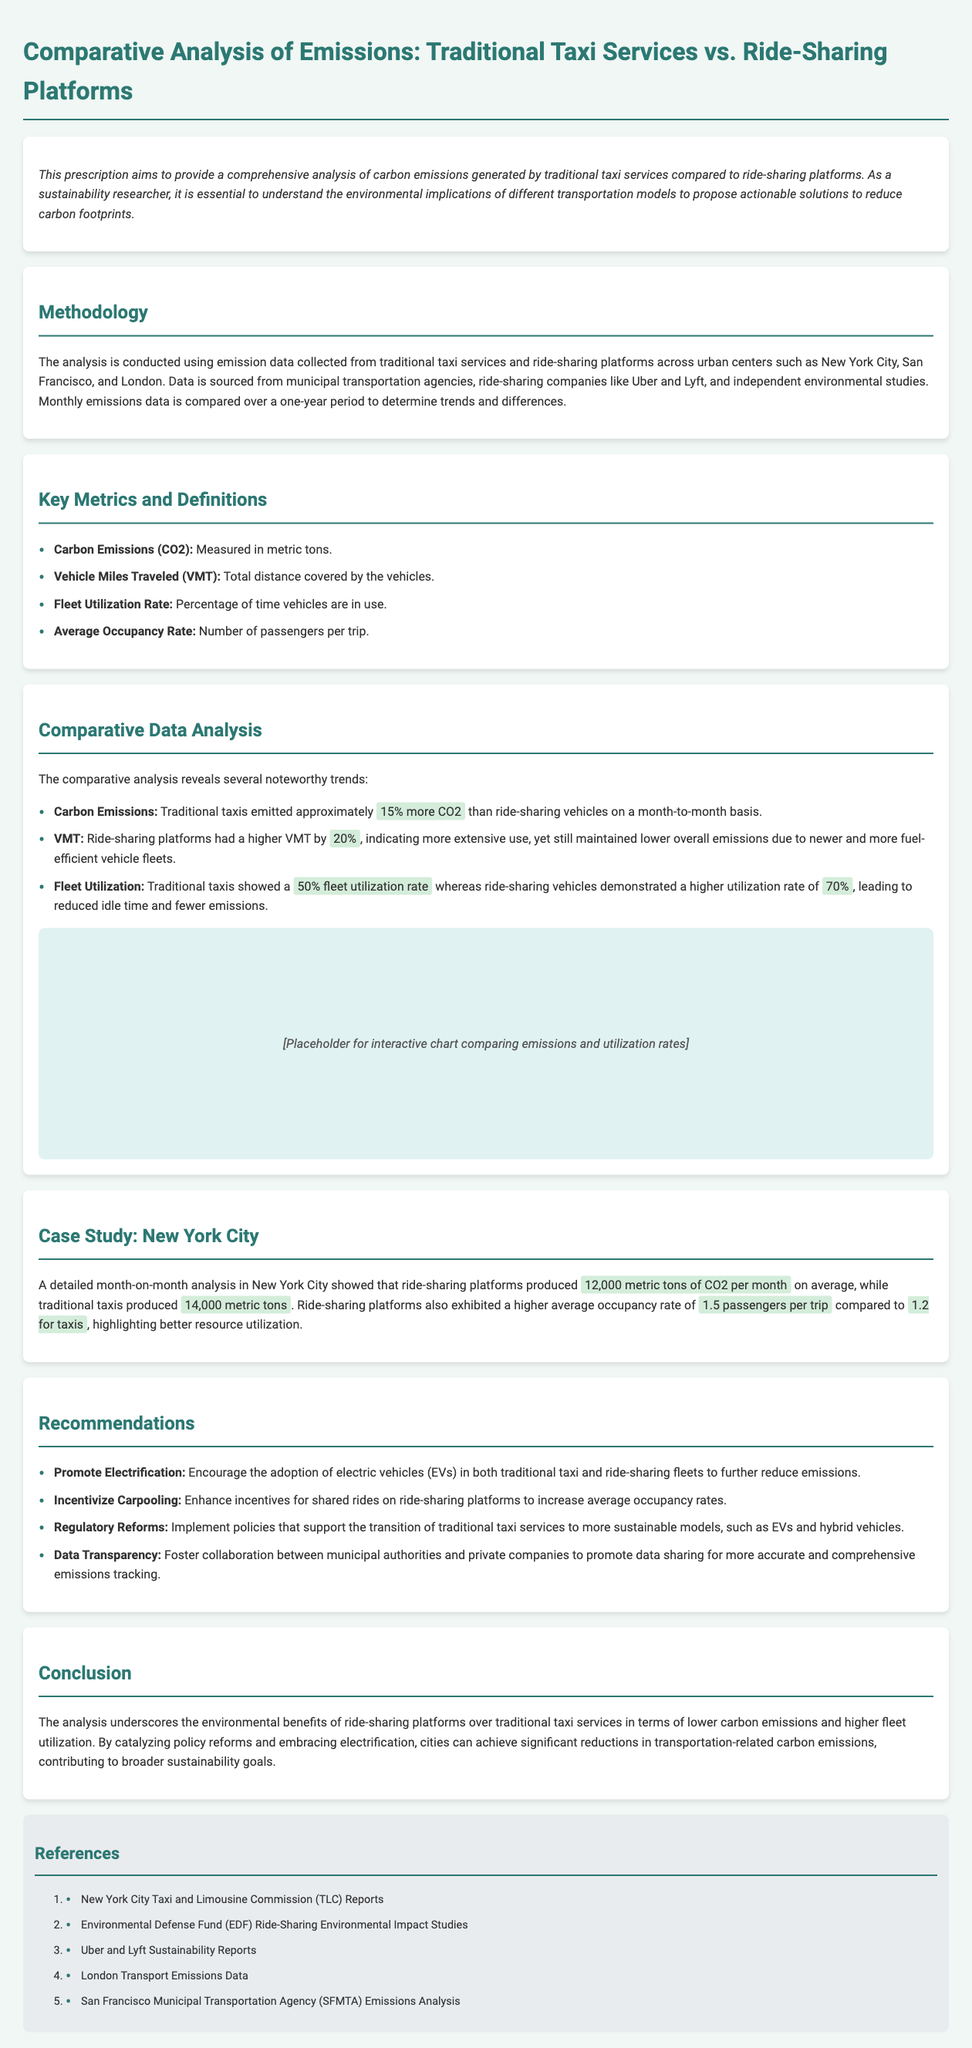what is the average carbon emissions for ride-sharing platforms in New York City? The document states that ride-sharing platforms produced 12,000 metric tons of CO2 per month on average in New York City.
Answer: 12,000 metric tons what percentage more CO2 do traditional taxis emit compared to ride-sharing vehicles? The document indicates that traditional taxis emitted approximately 15% more CO2 than ride-sharing vehicles.
Answer: 15% what is the fleet utilization rate for ride-sharing vehicles? According to the comparative analysis, ride-sharing vehicles demonstrated a higher utilization rate of 70%.
Answer: 70% what is the average occupancy rate for traditional taxis? The document specifies that traditional taxis have an average occupancy rate of 1.2 passengers per trip.
Answer: 1.2 passengers which urban centers were analyzed in the emissions comparison? The analysis includes urban centers such as New York City, San Francisco, and London.
Answer: New York City, San Francisco, London what is one recommendation given in the document? The document provides several recommendations, one of which is to promote the electrification of taxi and ride-sharing fleets.
Answer: Promote Electrification what year does the month-to-month analysis cover? The document does not specify a year, but the analysis spans a one-year period for gathering data.
Answer: One-year period how much more CO2 do traditional taxis produce monthly compared to ride-sharing platforms in New York City? The comparison shows that traditional taxis produced 14,000 metric tons while ride-sharing platforms produced 12,000 metric tons, indicating a difference of 2,000 metric tons monthly.
Answer: 2,000 metric tons what data sources were used for this emissions analysis? Data is sourced from municipal transportation agencies, ride-sharing companies like Uber and Lyft, and independent environmental studies.
Answer: Municipal transportation agencies, ride-sharing companies, independent environmental studies 